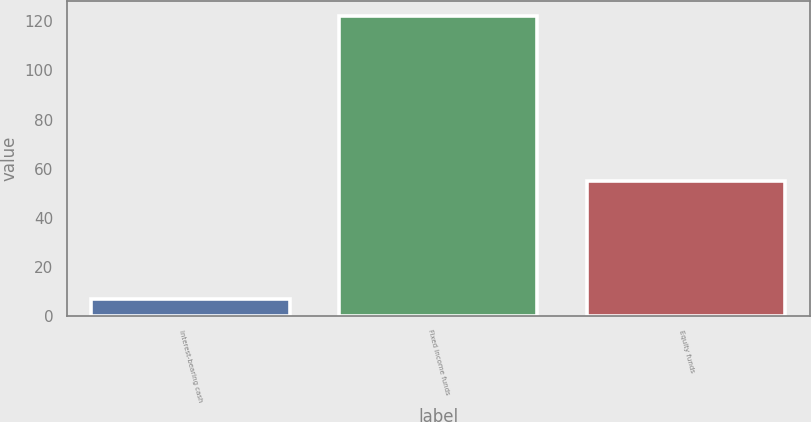<chart> <loc_0><loc_0><loc_500><loc_500><bar_chart><fcel>Interest-bearing cash<fcel>Fixed income funds<fcel>Equity funds<nl><fcel>6.8<fcel>122<fcel>55<nl></chart> 